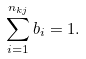Convert formula to latex. <formula><loc_0><loc_0><loc_500><loc_500>\sum _ { i = 1 } ^ { n _ { k j } } b _ { i } = 1 .</formula> 